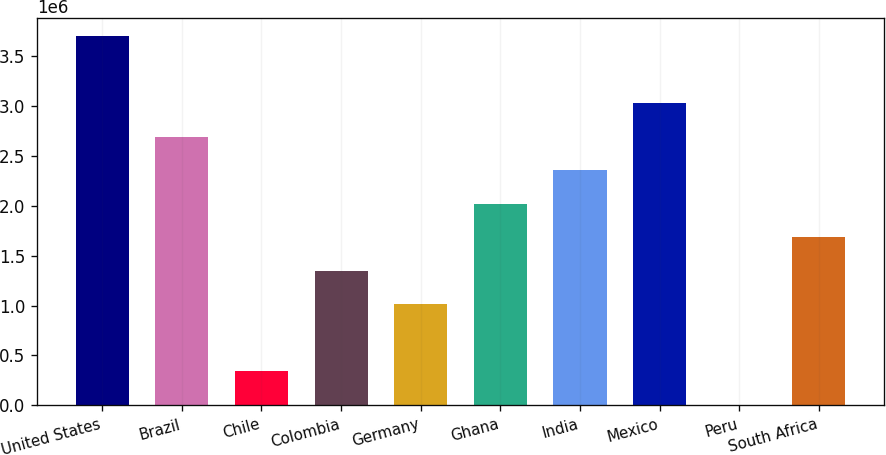Convert chart. <chart><loc_0><loc_0><loc_500><loc_500><bar_chart><fcel>United States<fcel>Brazil<fcel>Chile<fcel>Colombia<fcel>Germany<fcel>Ghana<fcel>India<fcel>Mexico<fcel>Peru<fcel>South Africa<nl><fcel>3.69697e+06<fcel>2.69029e+06<fcel>341382<fcel>1.34806e+06<fcel>1.0125e+06<fcel>2.01917e+06<fcel>2.35473e+06<fcel>3.02585e+06<fcel>5824<fcel>1.68362e+06<nl></chart> 